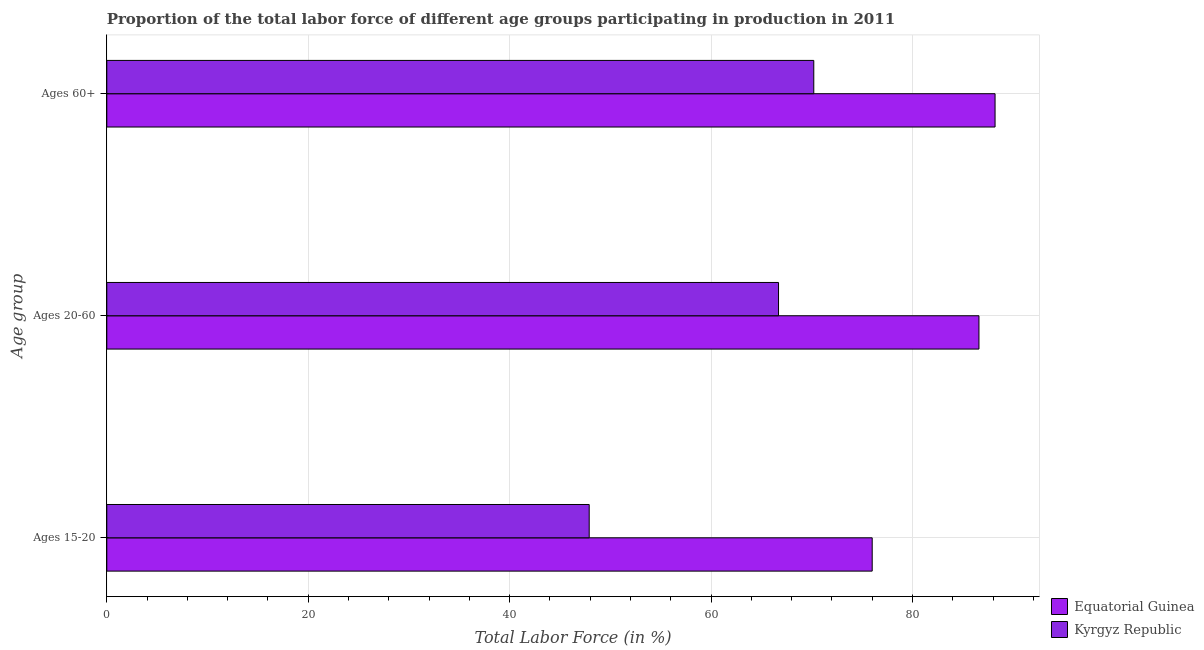How many groups of bars are there?
Your response must be concise. 3. Are the number of bars on each tick of the Y-axis equal?
Offer a terse response. Yes. How many bars are there on the 3rd tick from the top?
Provide a short and direct response. 2. What is the label of the 2nd group of bars from the top?
Offer a very short reply. Ages 20-60. What is the percentage of labor force above age 60 in Equatorial Guinea?
Give a very brief answer. 88.2. Across all countries, what is the maximum percentage of labor force within the age group 20-60?
Provide a succinct answer. 86.6. Across all countries, what is the minimum percentage of labor force above age 60?
Give a very brief answer. 70.2. In which country was the percentage of labor force above age 60 maximum?
Provide a succinct answer. Equatorial Guinea. In which country was the percentage of labor force within the age group 15-20 minimum?
Your answer should be very brief. Kyrgyz Republic. What is the total percentage of labor force above age 60 in the graph?
Offer a terse response. 158.4. What is the difference between the percentage of labor force above age 60 in Kyrgyz Republic and that in Equatorial Guinea?
Your answer should be very brief. -18. What is the difference between the percentage of labor force within the age group 20-60 in Kyrgyz Republic and the percentage of labor force within the age group 15-20 in Equatorial Guinea?
Offer a very short reply. -9.3. What is the average percentage of labor force within the age group 15-20 per country?
Provide a short and direct response. 61.95. What is the difference between the percentage of labor force above age 60 and percentage of labor force within the age group 15-20 in Kyrgyz Republic?
Offer a very short reply. 22.3. In how many countries, is the percentage of labor force within the age group 15-20 greater than 48 %?
Make the answer very short. 1. What is the ratio of the percentage of labor force within the age group 20-60 in Kyrgyz Republic to that in Equatorial Guinea?
Keep it short and to the point. 0.77. Is the percentage of labor force within the age group 20-60 in Equatorial Guinea less than that in Kyrgyz Republic?
Offer a very short reply. No. Is the difference between the percentage of labor force within the age group 20-60 in Equatorial Guinea and Kyrgyz Republic greater than the difference between the percentage of labor force above age 60 in Equatorial Guinea and Kyrgyz Republic?
Your answer should be compact. Yes. What is the difference between the highest and the second highest percentage of labor force within the age group 20-60?
Provide a succinct answer. 19.9. What is the difference between the highest and the lowest percentage of labor force within the age group 15-20?
Your answer should be very brief. 28.1. What does the 2nd bar from the top in Ages 60+ represents?
Ensure brevity in your answer.  Equatorial Guinea. What does the 1st bar from the bottom in Ages 20-60 represents?
Give a very brief answer. Equatorial Guinea. How many bars are there?
Make the answer very short. 6. What is the difference between two consecutive major ticks on the X-axis?
Your answer should be compact. 20. Where does the legend appear in the graph?
Offer a terse response. Bottom right. How many legend labels are there?
Keep it short and to the point. 2. What is the title of the graph?
Offer a terse response. Proportion of the total labor force of different age groups participating in production in 2011. What is the label or title of the Y-axis?
Provide a succinct answer. Age group. What is the Total Labor Force (in %) in Equatorial Guinea in Ages 15-20?
Provide a succinct answer. 76. What is the Total Labor Force (in %) in Kyrgyz Republic in Ages 15-20?
Provide a short and direct response. 47.9. What is the Total Labor Force (in %) in Equatorial Guinea in Ages 20-60?
Your response must be concise. 86.6. What is the Total Labor Force (in %) of Kyrgyz Republic in Ages 20-60?
Provide a succinct answer. 66.7. What is the Total Labor Force (in %) of Equatorial Guinea in Ages 60+?
Offer a very short reply. 88.2. What is the Total Labor Force (in %) in Kyrgyz Republic in Ages 60+?
Ensure brevity in your answer.  70.2. Across all Age group, what is the maximum Total Labor Force (in %) in Equatorial Guinea?
Provide a short and direct response. 88.2. Across all Age group, what is the maximum Total Labor Force (in %) of Kyrgyz Republic?
Your answer should be very brief. 70.2. Across all Age group, what is the minimum Total Labor Force (in %) in Equatorial Guinea?
Offer a very short reply. 76. Across all Age group, what is the minimum Total Labor Force (in %) of Kyrgyz Republic?
Provide a succinct answer. 47.9. What is the total Total Labor Force (in %) in Equatorial Guinea in the graph?
Make the answer very short. 250.8. What is the total Total Labor Force (in %) in Kyrgyz Republic in the graph?
Provide a short and direct response. 184.8. What is the difference between the Total Labor Force (in %) in Equatorial Guinea in Ages 15-20 and that in Ages 20-60?
Offer a very short reply. -10.6. What is the difference between the Total Labor Force (in %) of Kyrgyz Republic in Ages 15-20 and that in Ages 20-60?
Keep it short and to the point. -18.8. What is the difference between the Total Labor Force (in %) of Equatorial Guinea in Ages 15-20 and that in Ages 60+?
Your response must be concise. -12.2. What is the difference between the Total Labor Force (in %) of Kyrgyz Republic in Ages 15-20 and that in Ages 60+?
Keep it short and to the point. -22.3. What is the difference between the Total Labor Force (in %) of Equatorial Guinea in Ages 20-60 and the Total Labor Force (in %) of Kyrgyz Republic in Ages 60+?
Give a very brief answer. 16.4. What is the average Total Labor Force (in %) in Equatorial Guinea per Age group?
Your answer should be very brief. 83.6. What is the average Total Labor Force (in %) in Kyrgyz Republic per Age group?
Ensure brevity in your answer.  61.6. What is the difference between the Total Labor Force (in %) of Equatorial Guinea and Total Labor Force (in %) of Kyrgyz Republic in Ages 15-20?
Ensure brevity in your answer.  28.1. What is the difference between the Total Labor Force (in %) of Equatorial Guinea and Total Labor Force (in %) of Kyrgyz Republic in Ages 60+?
Provide a succinct answer. 18. What is the ratio of the Total Labor Force (in %) of Equatorial Guinea in Ages 15-20 to that in Ages 20-60?
Offer a terse response. 0.88. What is the ratio of the Total Labor Force (in %) in Kyrgyz Republic in Ages 15-20 to that in Ages 20-60?
Make the answer very short. 0.72. What is the ratio of the Total Labor Force (in %) in Equatorial Guinea in Ages 15-20 to that in Ages 60+?
Your response must be concise. 0.86. What is the ratio of the Total Labor Force (in %) of Kyrgyz Republic in Ages 15-20 to that in Ages 60+?
Your answer should be very brief. 0.68. What is the ratio of the Total Labor Force (in %) in Equatorial Guinea in Ages 20-60 to that in Ages 60+?
Give a very brief answer. 0.98. What is the ratio of the Total Labor Force (in %) in Kyrgyz Republic in Ages 20-60 to that in Ages 60+?
Offer a terse response. 0.95. What is the difference between the highest and the second highest Total Labor Force (in %) in Kyrgyz Republic?
Your answer should be compact. 3.5. What is the difference between the highest and the lowest Total Labor Force (in %) in Equatorial Guinea?
Ensure brevity in your answer.  12.2. What is the difference between the highest and the lowest Total Labor Force (in %) of Kyrgyz Republic?
Keep it short and to the point. 22.3. 